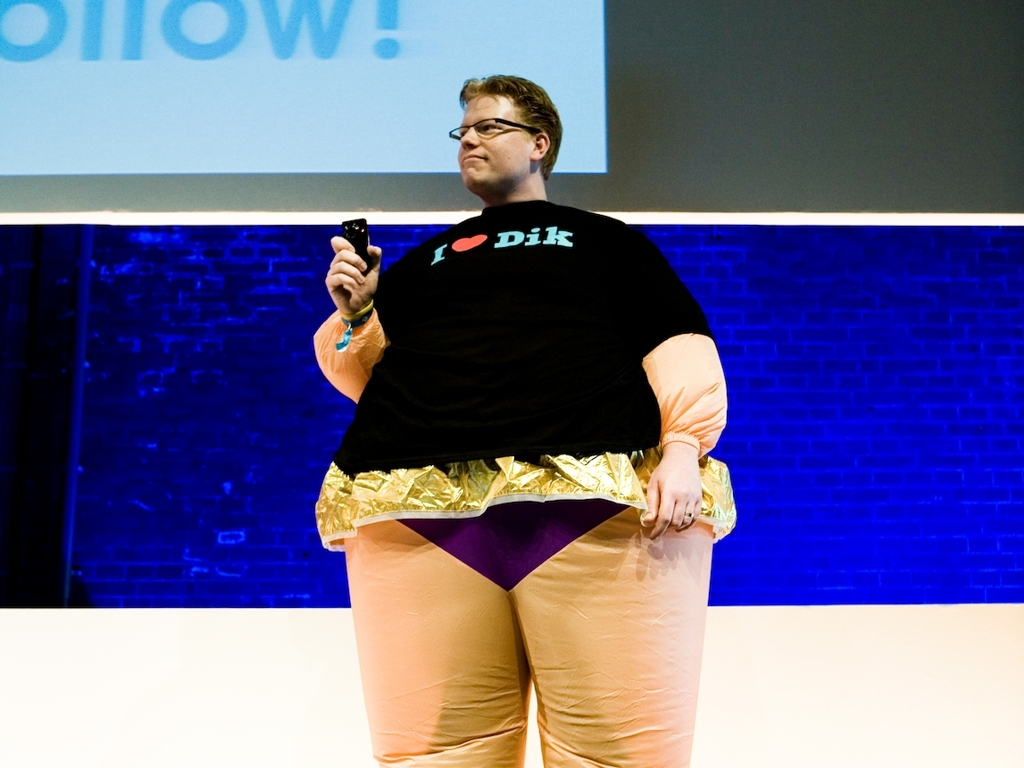Can you describe the attire of the person in the image? The person in the image is wearing a unique ensemble that includes a black T-shirt with a heart and text design, gold foil pants, and a peach-colored fabric around the lower part of their body. They are also holding a small black object in their hand. 